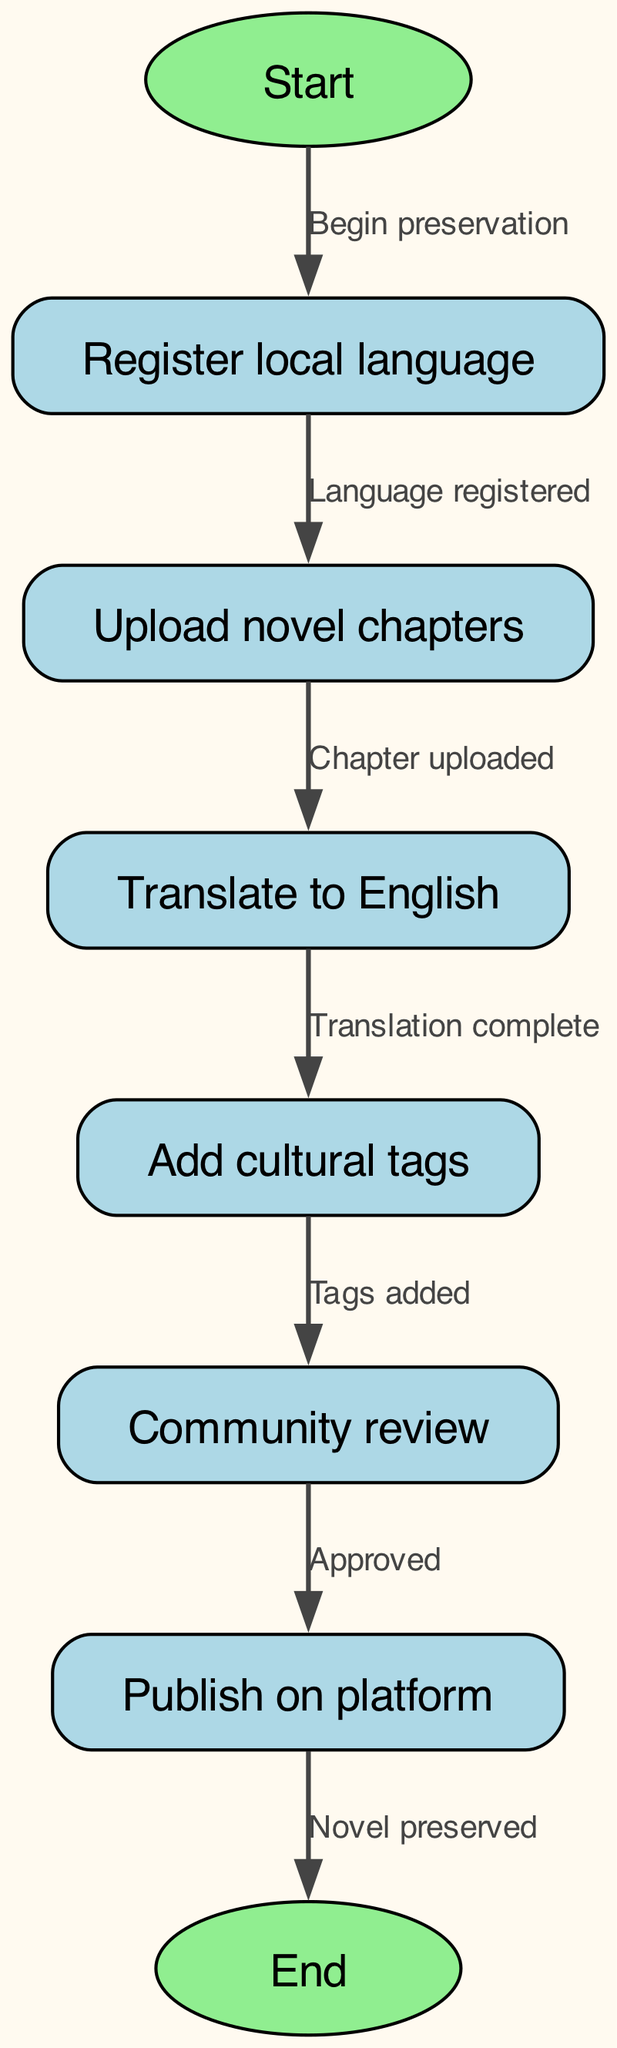What is the first step in the flowchart? The flowchart begins at the 'Start' node, which indicates the initiation of the process.
Answer: Start How many nodes are there in the diagram? The diagram contains a total of eight nodes: start, register, upload, translate, tags, review, publish, and end.
Answer: Eight What does the node 'upload' connect to? The 'upload' node has a direct edge that leads to the 'translate' node, indicating that after uploading, the next step is translation.
Answer: Translate What must happen before publishing the novel? The previous step, 'review', must be completed and approved before the publishing step can occur.
Answer: Approved What is indicated by the edge from 'tags' to 'review'? This edge shows that once cultural tags are added in the 'tags' node, the process moves to the 'review' node for community evaluation.
Answer: Tags added If a novel chapter is uploaded, what is the immediate next action? Following the 'upload' node, the next action is to 'translate' the uploaded chapter into English.
Answer: Translate What does the final step in the flowchart signify? The final step in the flowchart signifies that the novel has been successfully published and preserved on the platform.
Answer: Novel preserved How many edges are there connecting the nodes? There are six edges in the diagram, each showing the flow from one node to the next.
Answer: Six What action follows the completion of the translation? After the translation is completed, the next action is to add cultural tags to the translated content.
Answer: Add cultural tags What is the outcome of the flowchart process? The ultimate outcome of the process is the successful preservation of the novel on the platform.
Answer: End 